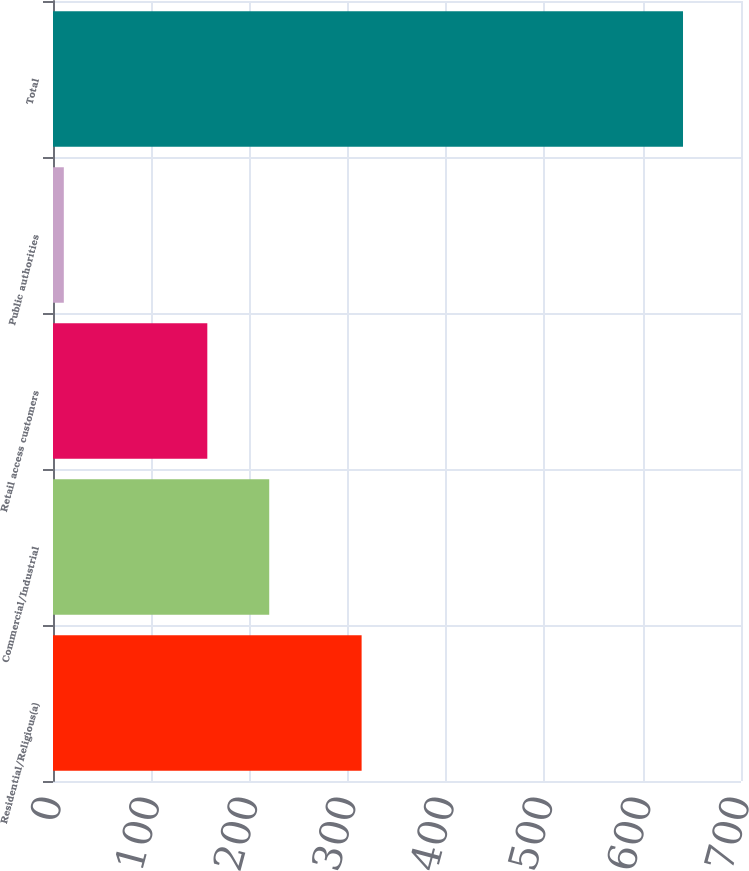<chart> <loc_0><loc_0><loc_500><loc_500><bar_chart><fcel>Residential/Religious(a)<fcel>Commercial/Industrial<fcel>Retail access customers<fcel>Public authorities<fcel>Total<nl><fcel>314<fcel>220<fcel>157<fcel>11<fcel>641<nl></chart> 